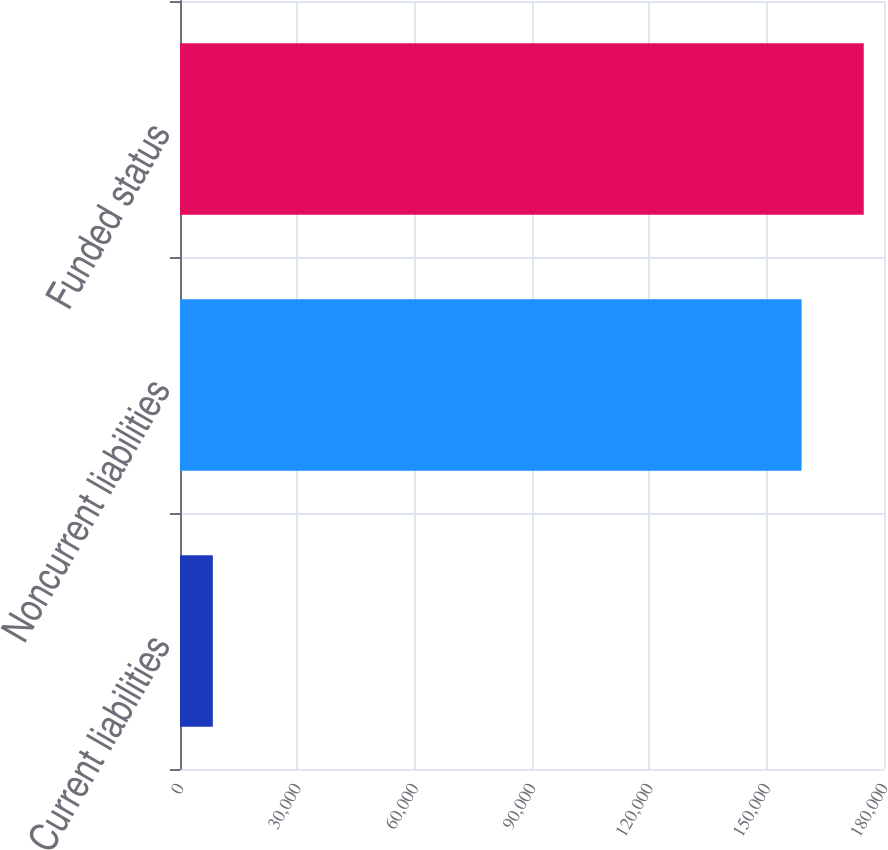Convert chart to OTSL. <chart><loc_0><loc_0><loc_500><loc_500><bar_chart><fcel>Current liabilities<fcel>Noncurrent liabilities<fcel>Funded status<nl><fcel>8398<fcel>158933<fcel>174826<nl></chart> 